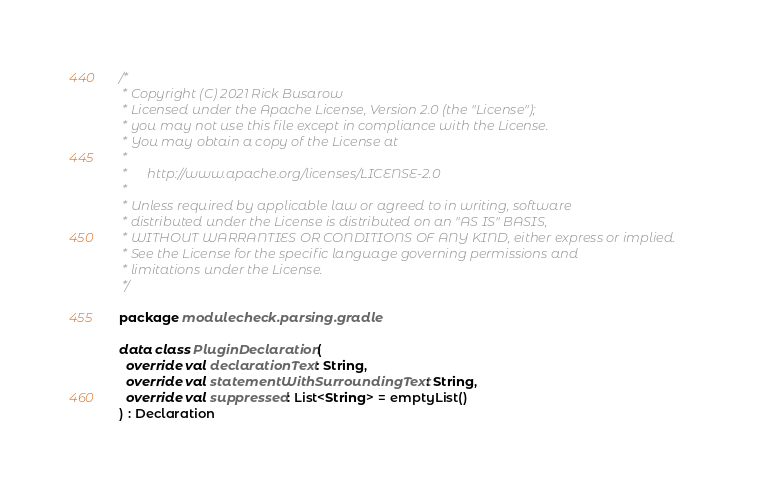Convert code to text. <code><loc_0><loc_0><loc_500><loc_500><_Kotlin_>/*
 * Copyright (C) 2021 Rick Busarow
 * Licensed under the Apache License, Version 2.0 (the "License");
 * you may not use this file except in compliance with the License.
 * You may obtain a copy of the License at
 *
 *      http://www.apache.org/licenses/LICENSE-2.0
 *
 * Unless required by applicable law or agreed to in writing, software
 * distributed under the License is distributed on an "AS IS" BASIS,
 * WITHOUT WARRANTIES OR CONDITIONS OF ANY KIND, either express or implied.
 * See the License for the specific language governing permissions and
 * limitations under the License.
 */

package modulecheck.parsing.gradle

data class PluginDeclaration(
  override val declarationText: String,
  override val statementWithSurroundingText: String,
  override val suppressed: List<String> = emptyList()
) : Declaration
</code> 